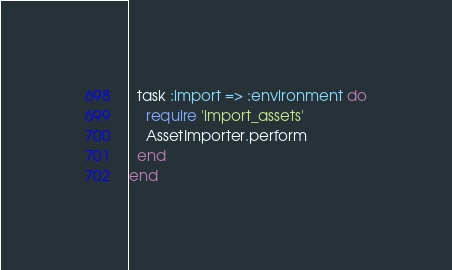<code> <loc_0><loc_0><loc_500><loc_500><_Ruby_>  task :import => :environment do
    require 'import_assets'
    AssetImporter.perform
  end
end</code> 